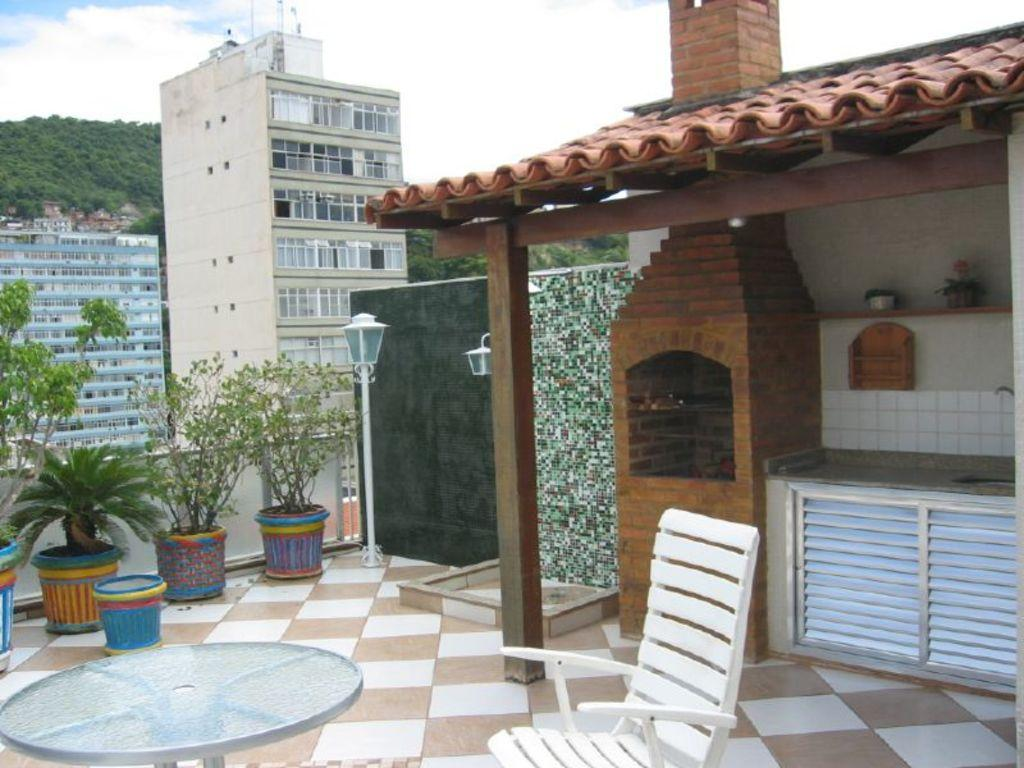What type of structures can be seen in the image? There are buildings in the image. What type of lighting is present in the image? There is a table lamp in the image. What type of vegetation is present in the image? There are houseplants in the image. What type of furniture is present in the image? There are chairs in the image. What type of outbuilding is present in the image? There is a shed in the image. What type of plumbing fixture is present in the image? There is a sink in the image. What type of water supply fixture is present in the image? There is a tap in the image. What can be seen in the sky in the image? The sky with clouds is visible in the image. What type of natural landform is present in the image? There is a hill in the image. Can you see the giraffe's teeth in the image? There is no giraffe present in the image, so it is not possible to see its teeth. What type of partner is sitting on the chair in the image? There is no person or partner present in the image, so it is not possible to determine who might be sitting on the chair. 